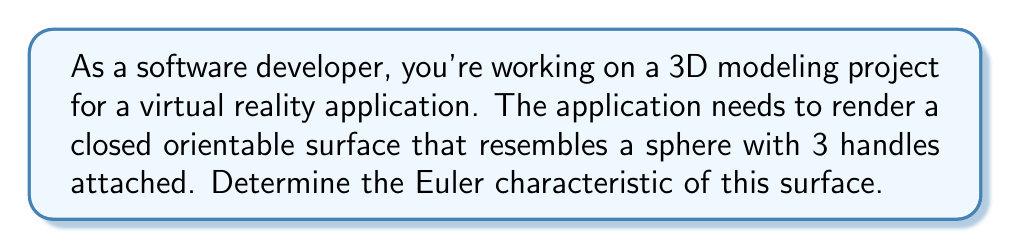Can you answer this question? To solve this problem, we'll use the following steps:

1) Recall the formula for the Euler characteristic of a closed orientable surface:
   
   $$\chi = 2 - 2g$$
   
   where $\chi$ is the Euler characteristic and $g$ is the genus (number of handles) of the surface.

2) In this case, we have a sphere (which has genus 0) with 3 additional handles attached. So the total genus is:
   
   $$g = 0 + 3 = 3$$

3) Now we can substitute this value into our formula:
   
   $$\chi = 2 - 2(3)$$
   $$\chi = 2 - 6$$
   $$\chi = -4$$

4) We can verify this result by considering the classification of closed orientable surfaces:
   - A sphere has Euler characteristic 2
   - Each handle reduces the Euler characteristic by 2
   - So a sphere with 3 handles should have Euler characteristic $2 - 3(2) = -4$

This confirms our calculation.

[asy]
import three;

size(200);
currentprojection=perspective(6,3,2);

// Draw the main sphere
draw(surface(sphere(O,1)),paleblue+opacity(.7));

// Draw the handles
path3 handle = (1,0,0)..(1.5,0,0.5)..(1,0,1);
for(int i=0; i<3; ++i) {
  draw(surface(revolution(rotate(120*i,Z)*handle,Z)),green+opacity(.7));
}
[/asy]
Answer: $\chi = -4$ 